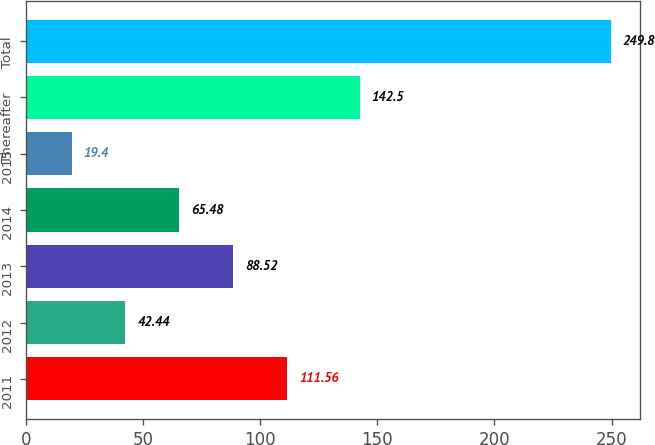<chart> <loc_0><loc_0><loc_500><loc_500><bar_chart><fcel>2011<fcel>2012<fcel>2013<fcel>2014<fcel>2015<fcel>Thereafter<fcel>Total<nl><fcel>111.56<fcel>42.44<fcel>88.52<fcel>65.48<fcel>19.4<fcel>142.5<fcel>249.8<nl></chart> 